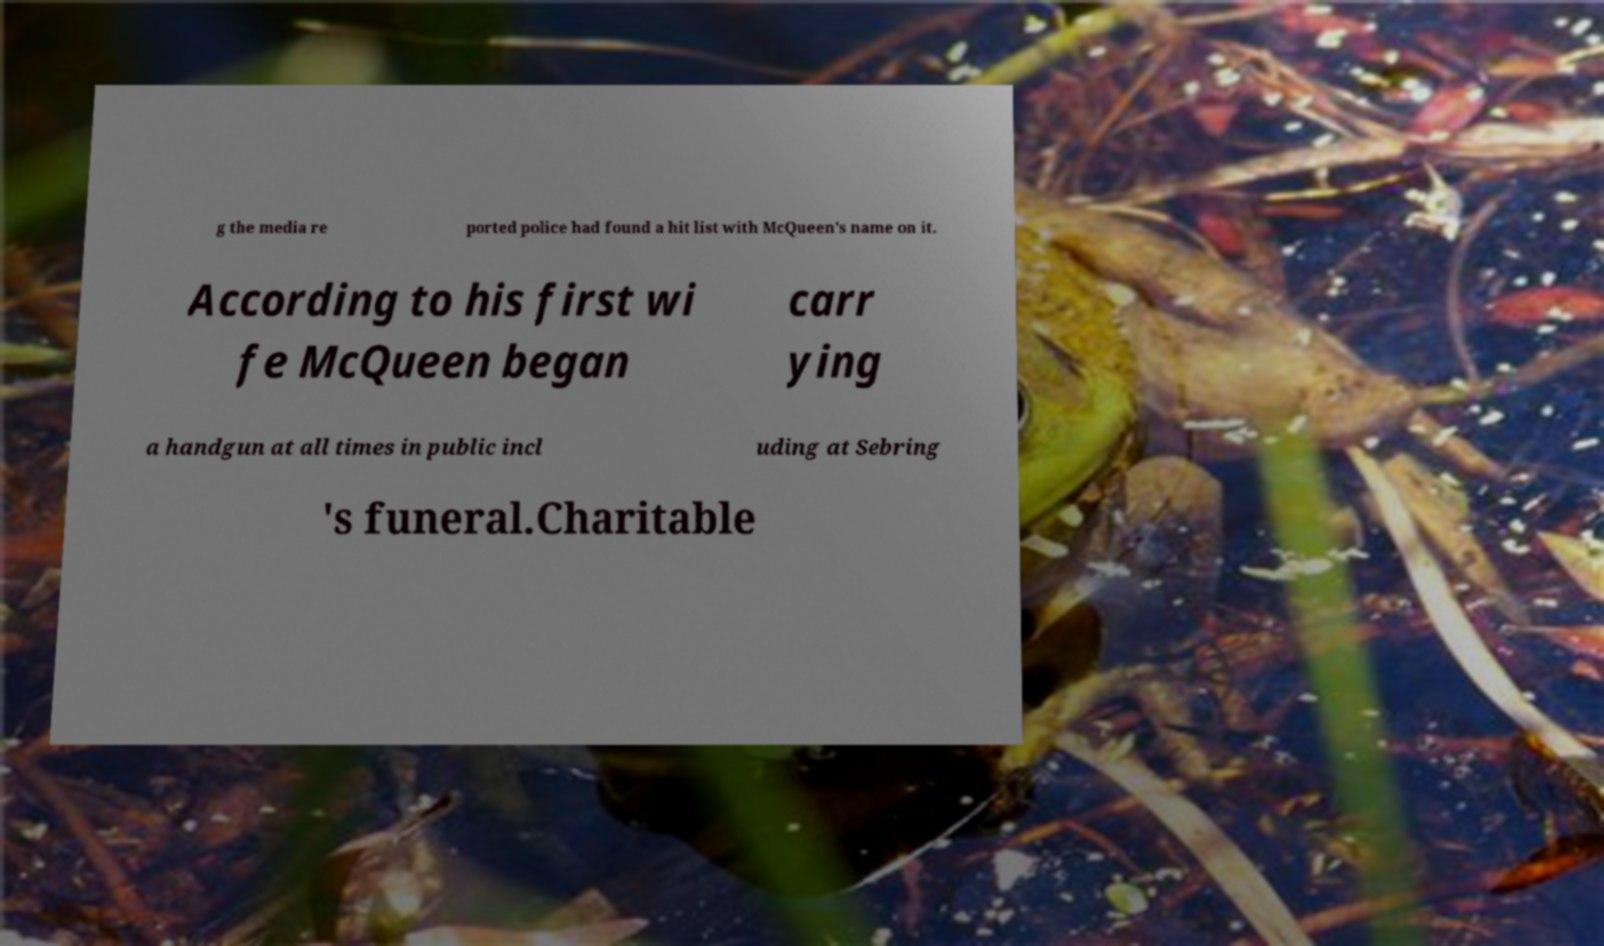Please identify and transcribe the text found in this image. g the media re ported police had found a hit list with McQueen's name on it. According to his first wi fe McQueen began carr ying a handgun at all times in public incl uding at Sebring 's funeral.Charitable 